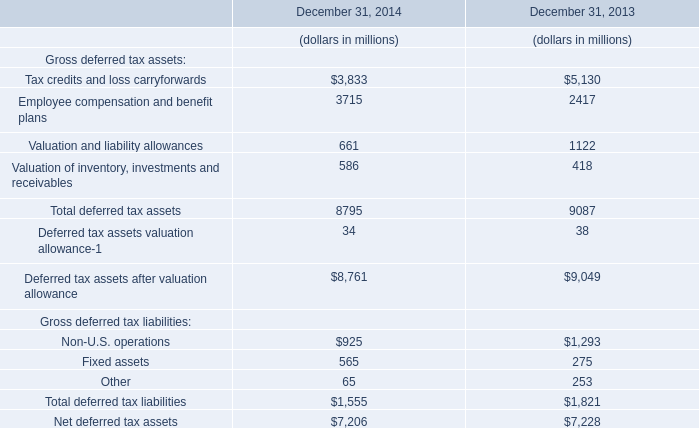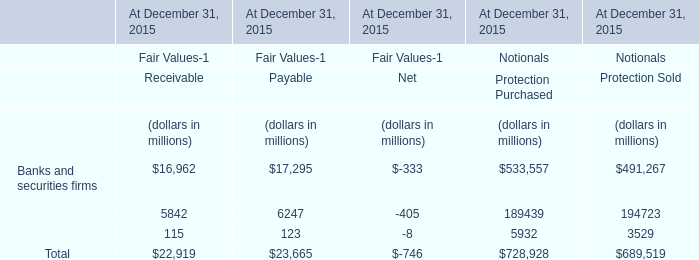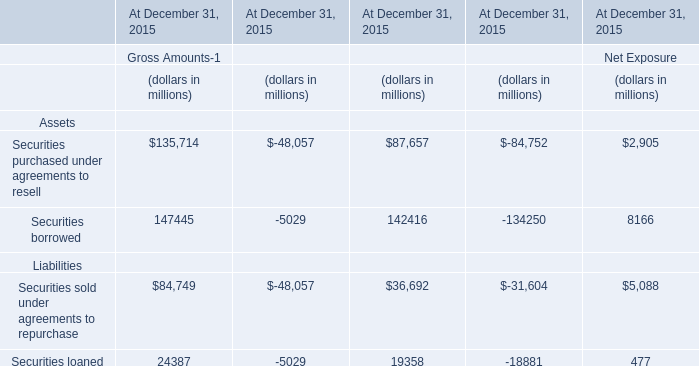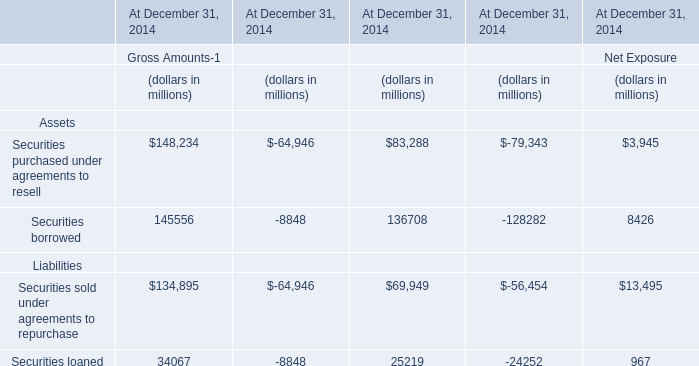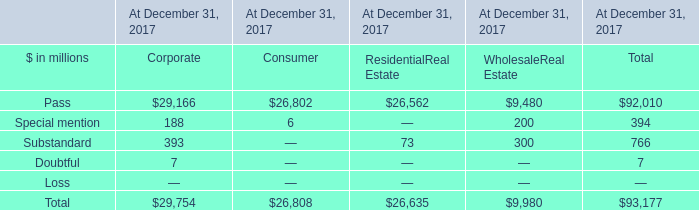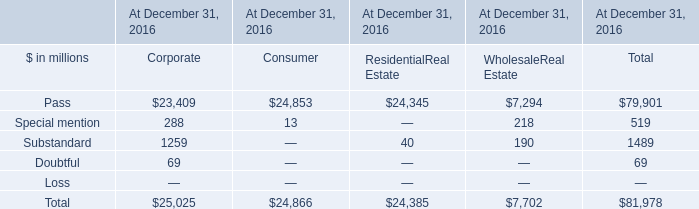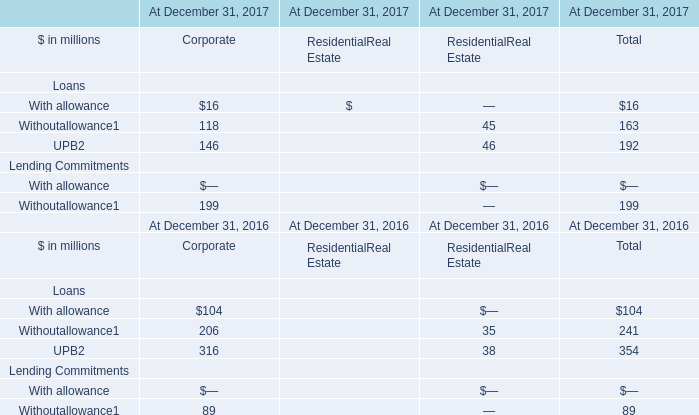What's the total value of all Substandard that are smaller than 200 in 2016 (in million) 
Computations: (40 + 190)
Answer: 230.0. 